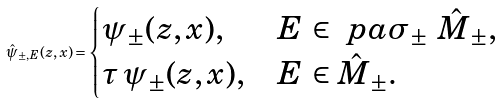<formula> <loc_0><loc_0><loc_500><loc_500>\hat { \psi } _ { \pm , E } ( z , x ) = \begin{cases} \psi _ { \pm } ( z , x ) , & E \, \in \ p a \sigma _ { \pm } \ \hat { M } _ { \pm } , \\ \tau \, \psi _ { \pm } ( z , x ) , & E \, \in \hat { M } _ { \pm } . \end{cases}</formula> 